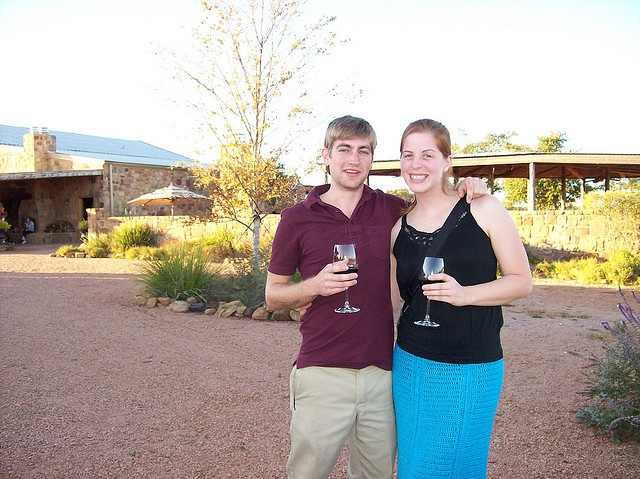Describe the objects in this image and their specific colors. I can see people in white, black, lightblue, lightgray, and lightpink tones, people in white, purple, darkgray, and lightpink tones, umbrella in white, ivory, gray, orange, and tan tones, wine glass in white, black, and gray tones, and wine glass in white, darkgray, lightgray, purple, and gray tones in this image. 